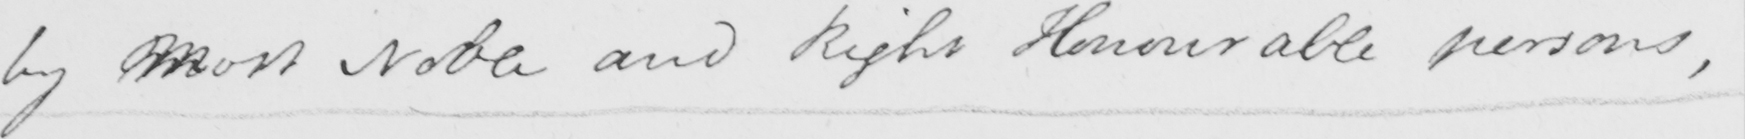What text is written in this handwritten line? by mMost Noble and Right Honourable persons , 